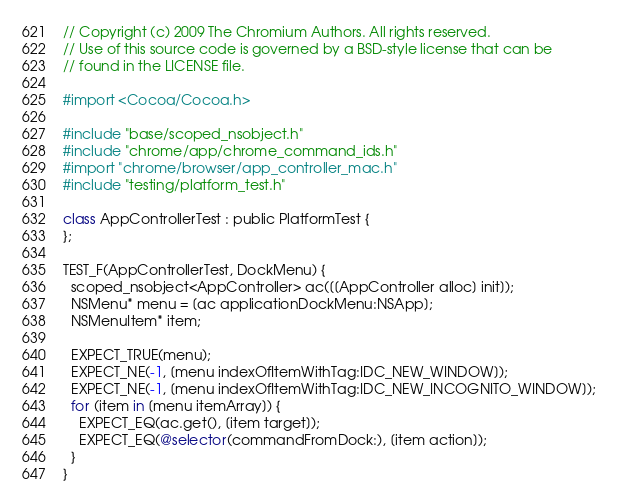<code> <loc_0><loc_0><loc_500><loc_500><_ObjectiveC_>// Copyright (c) 2009 The Chromium Authors. All rights reserved.
// Use of this source code is governed by a BSD-style license that can be
// found in the LICENSE file.

#import <Cocoa/Cocoa.h>

#include "base/scoped_nsobject.h"
#include "chrome/app/chrome_command_ids.h"
#import "chrome/browser/app_controller_mac.h"
#include "testing/platform_test.h"

class AppControllerTest : public PlatformTest {
};

TEST_F(AppControllerTest, DockMenu) {
  scoped_nsobject<AppController> ac([[AppController alloc] init]);
  NSMenu* menu = [ac applicationDockMenu:NSApp];
  NSMenuItem* item;

  EXPECT_TRUE(menu);
  EXPECT_NE(-1, [menu indexOfItemWithTag:IDC_NEW_WINDOW]);
  EXPECT_NE(-1, [menu indexOfItemWithTag:IDC_NEW_INCOGNITO_WINDOW]);
  for (item in [menu itemArray]) {
    EXPECT_EQ(ac.get(), [item target]);
    EXPECT_EQ(@selector(commandFromDock:), [item action]);
  }
}
</code> 